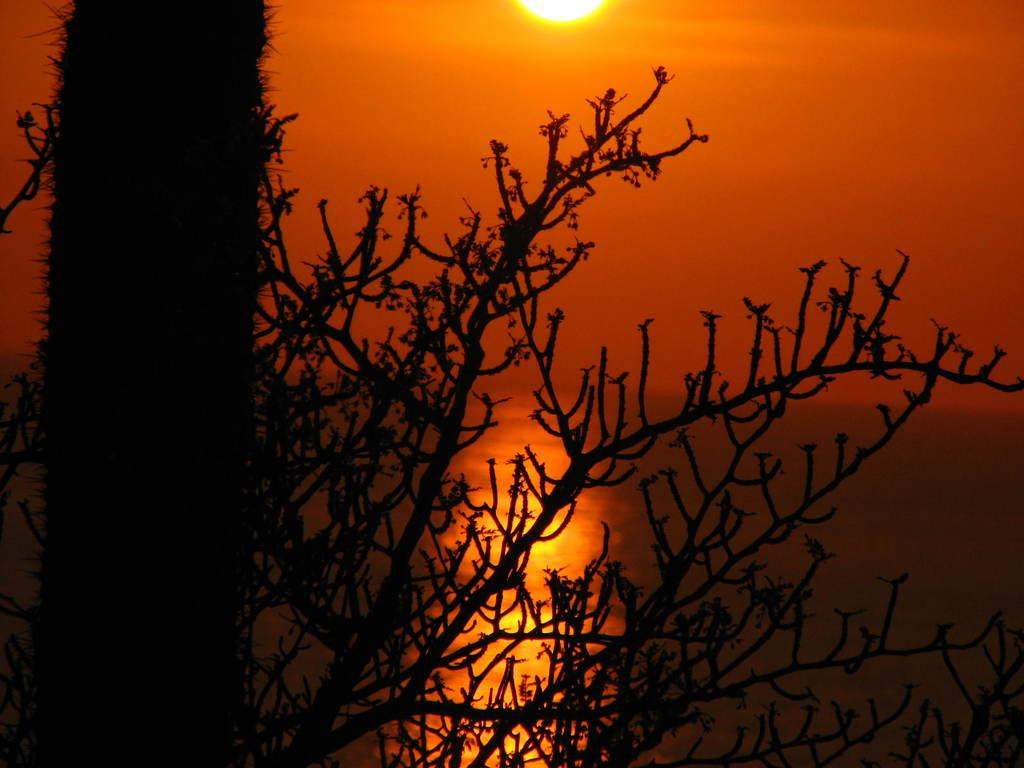What is located at the front of the image? There is a tree in the front of the image. What can be seen in the background of the image? There appears to be water in the background of the image. What is visible in the image besides the tree and water? The sky is visible in the image. Can the sun be seen in the image? Yes, the sun is observable at the top of the image. What type of note or advertisement is attached to the tree in the image? There is no note or advertisement attached to the tree in the image. Can you see any jellyfish in the water in the background of the image? There are no jellyfish present in the image; it only features a tree, water, sky, and the sun. 